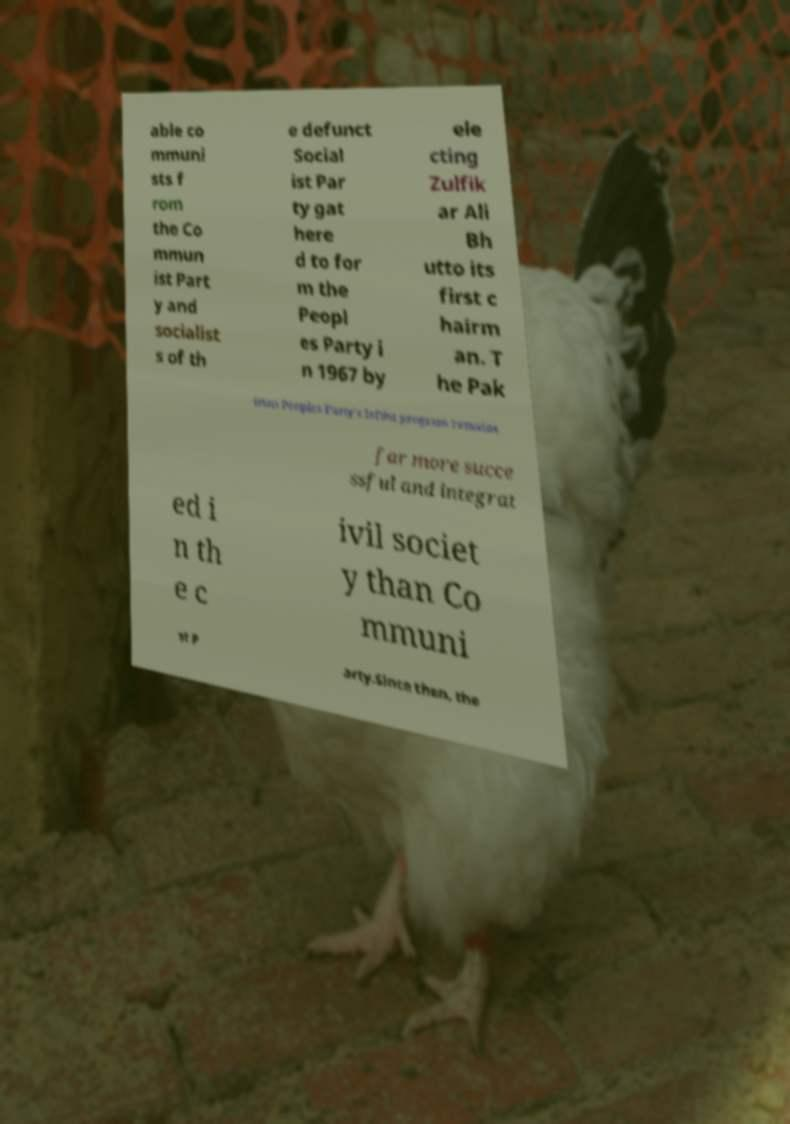Please read and relay the text visible in this image. What does it say? able co mmuni sts f rom the Co mmun ist Part y and socialist s of th e defunct Social ist Par ty gat here d to for m the Peopl es Party i n 1967 by ele cting Zulfik ar Ali Bh utto its first c hairm an. T he Pak istan Peoples Party's leftist program remains far more succe ssful and integrat ed i n th e c ivil societ y than Co mmuni st P arty.Since then, the 